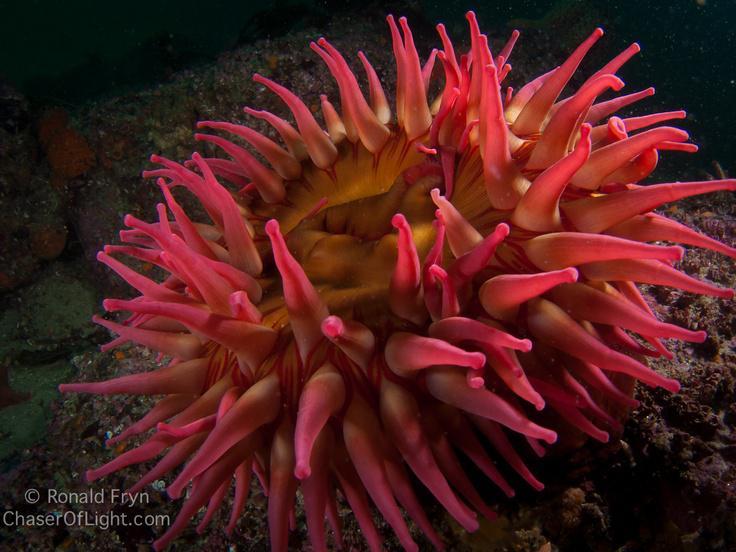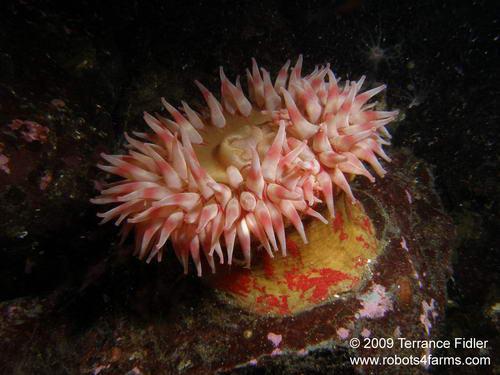The first image is the image on the left, the second image is the image on the right. Assess this claim about the two images: "There are at least two creatures in the image on the left.". Correct or not? Answer yes or no. No. 